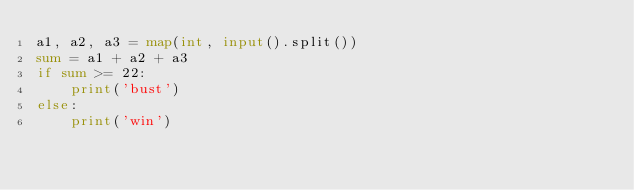<code> <loc_0><loc_0><loc_500><loc_500><_Python_>a1, a2, a3 = map(int, input().split())
sum = a1 + a2 + a3
if sum >= 22:
    print('bust')
else:
    print('win')
</code> 